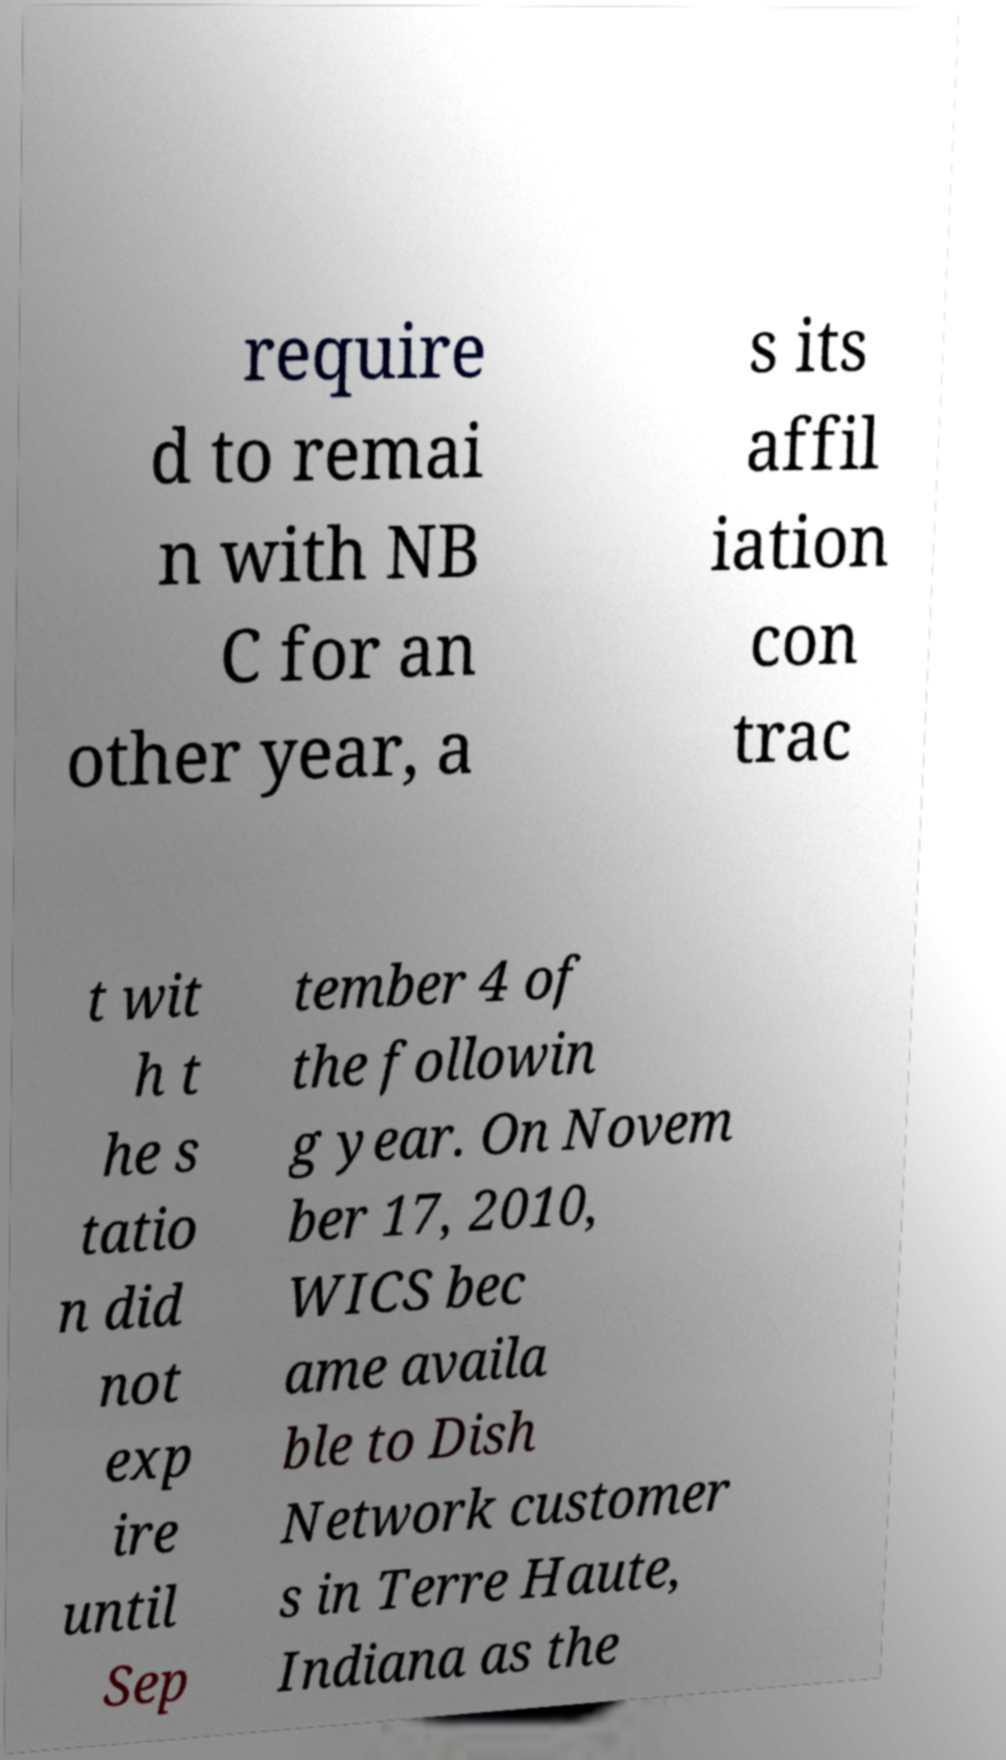For documentation purposes, I need the text within this image transcribed. Could you provide that? require d to remai n with NB C for an other year, a s its affil iation con trac t wit h t he s tatio n did not exp ire until Sep tember 4 of the followin g year. On Novem ber 17, 2010, WICS bec ame availa ble to Dish Network customer s in Terre Haute, Indiana as the 